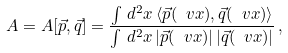<formula> <loc_0><loc_0><loc_500><loc_500>A = A [ \vec { p } , \vec { q } ] = \frac { \int \, d ^ { 2 } x \, \langle \vec { p } ( \ v x ) , \vec { q } ( \ v x ) \rangle } { \int \, d ^ { 2 } x \, | \vec { p } ( \ v x ) | \, | \vec { q } ( \ v x ) | } \, ,</formula> 